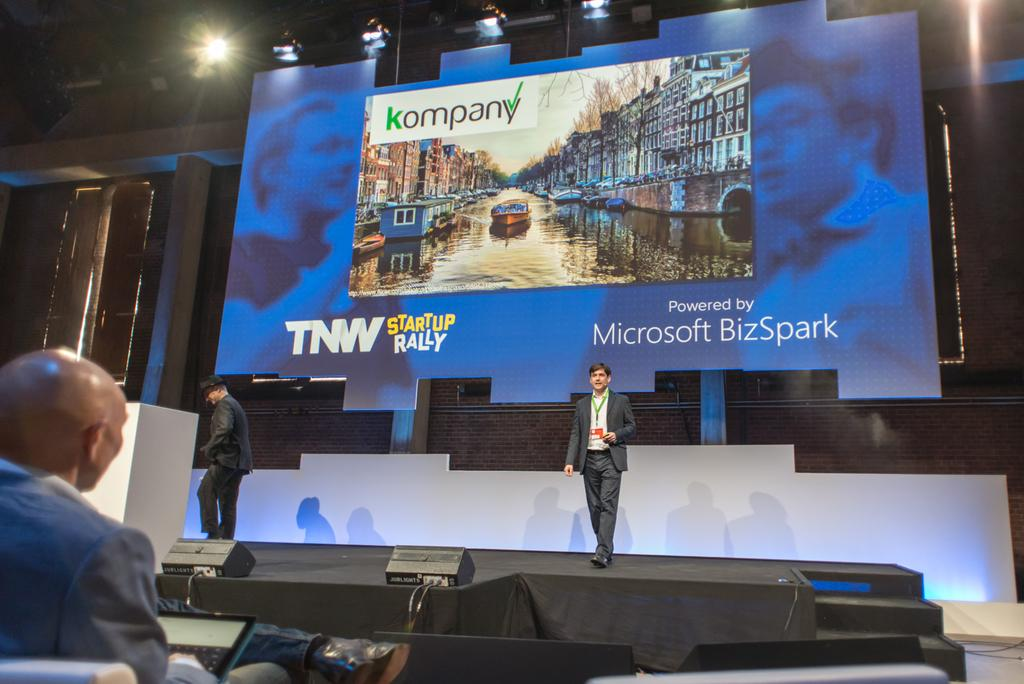Provide a one-sentence caption for the provided image. Big screen shows kompany TNW startup Rally powered by Microsoft Bizspark. 